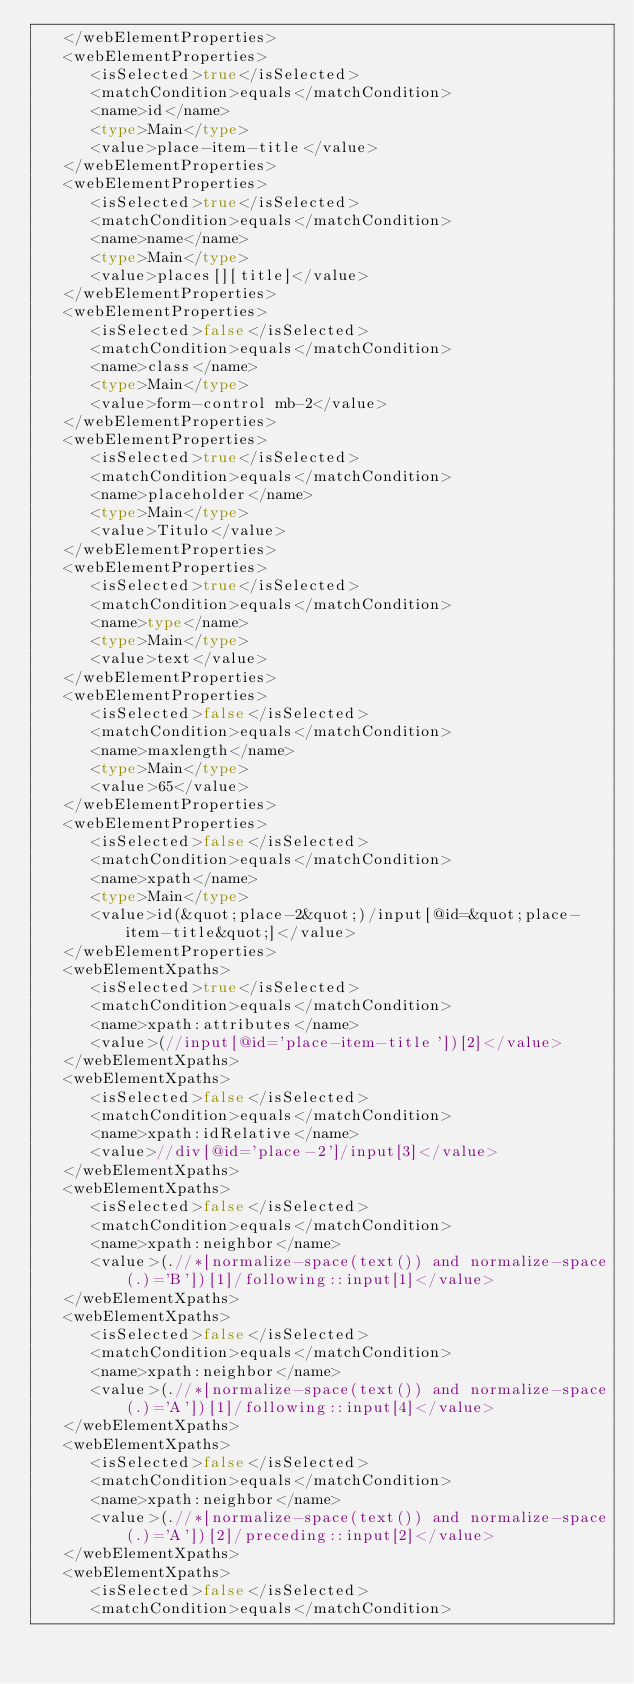<code> <loc_0><loc_0><loc_500><loc_500><_Rust_>   </webElementProperties>
   <webElementProperties>
      <isSelected>true</isSelected>
      <matchCondition>equals</matchCondition>
      <name>id</name>
      <type>Main</type>
      <value>place-item-title</value>
   </webElementProperties>
   <webElementProperties>
      <isSelected>true</isSelected>
      <matchCondition>equals</matchCondition>
      <name>name</name>
      <type>Main</type>
      <value>places[][title]</value>
   </webElementProperties>
   <webElementProperties>
      <isSelected>false</isSelected>
      <matchCondition>equals</matchCondition>
      <name>class</name>
      <type>Main</type>
      <value>form-control mb-2</value>
   </webElementProperties>
   <webElementProperties>
      <isSelected>true</isSelected>
      <matchCondition>equals</matchCondition>
      <name>placeholder</name>
      <type>Main</type>
      <value>Titulo</value>
   </webElementProperties>
   <webElementProperties>
      <isSelected>true</isSelected>
      <matchCondition>equals</matchCondition>
      <name>type</name>
      <type>Main</type>
      <value>text</value>
   </webElementProperties>
   <webElementProperties>
      <isSelected>false</isSelected>
      <matchCondition>equals</matchCondition>
      <name>maxlength</name>
      <type>Main</type>
      <value>65</value>
   </webElementProperties>
   <webElementProperties>
      <isSelected>false</isSelected>
      <matchCondition>equals</matchCondition>
      <name>xpath</name>
      <type>Main</type>
      <value>id(&quot;place-2&quot;)/input[@id=&quot;place-item-title&quot;]</value>
   </webElementProperties>
   <webElementXpaths>
      <isSelected>true</isSelected>
      <matchCondition>equals</matchCondition>
      <name>xpath:attributes</name>
      <value>(//input[@id='place-item-title'])[2]</value>
   </webElementXpaths>
   <webElementXpaths>
      <isSelected>false</isSelected>
      <matchCondition>equals</matchCondition>
      <name>xpath:idRelative</name>
      <value>//div[@id='place-2']/input[3]</value>
   </webElementXpaths>
   <webElementXpaths>
      <isSelected>false</isSelected>
      <matchCondition>equals</matchCondition>
      <name>xpath:neighbor</name>
      <value>(.//*[normalize-space(text()) and normalize-space(.)='B'])[1]/following::input[1]</value>
   </webElementXpaths>
   <webElementXpaths>
      <isSelected>false</isSelected>
      <matchCondition>equals</matchCondition>
      <name>xpath:neighbor</name>
      <value>(.//*[normalize-space(text()) and normalize-space(.)='A'])[1]/following::input[4]</value>
   </webElementXpaths>
   <webElementXpaths>
      <isSelected>false</isSelected>
      <matchCondition>equals</matchCondition>
      <name>xpath:neighbor</name>
      <value>(.//*[normalize-space(text()) and normalize-space(.)='A'])[2]/preceding::input[2]</value>
   </webElementXpaths>
   <webElementXpaths>
      <isSelected>false</isSelected>
      <matchCondition>equals</matchCondition></code> 